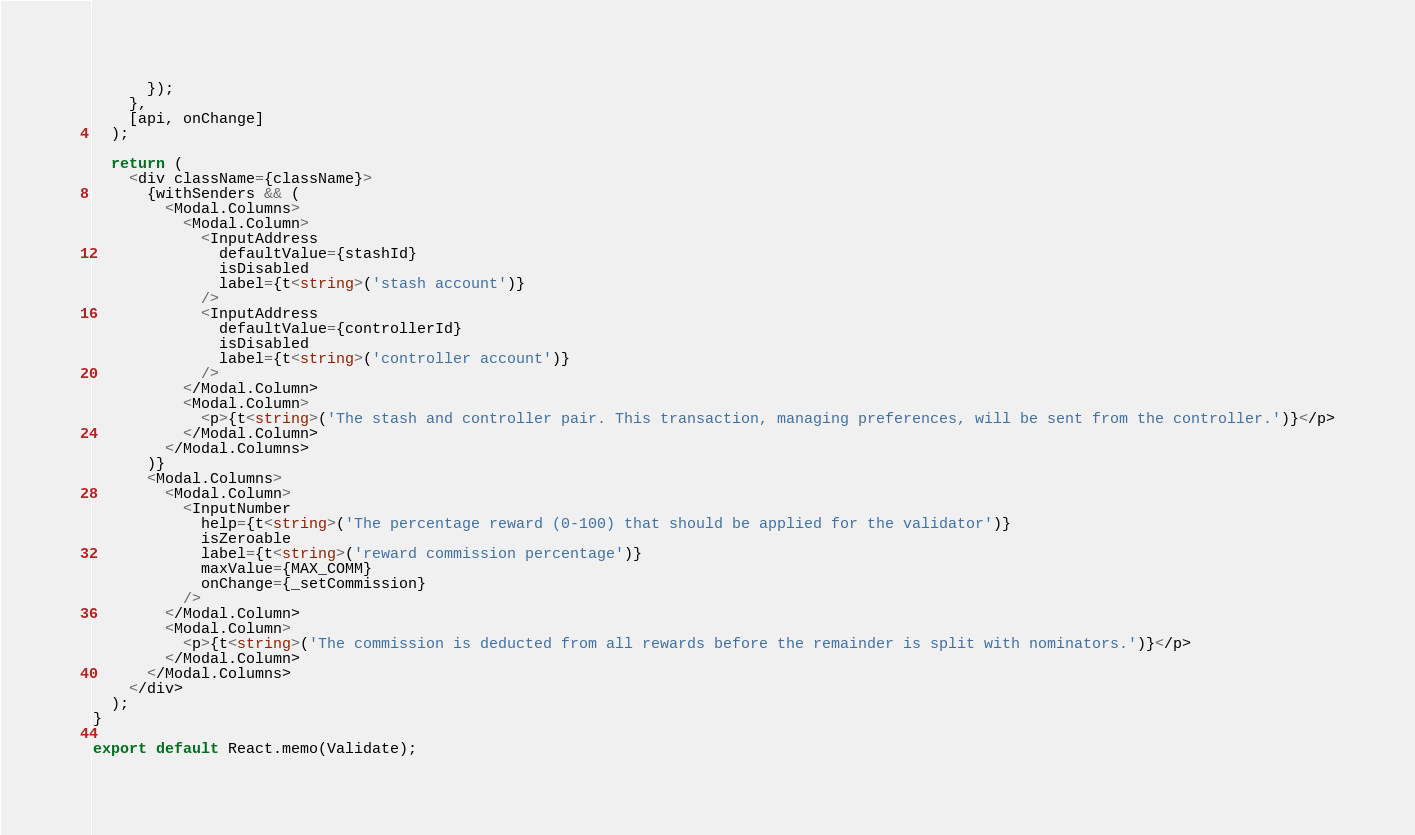Convert code to text. <code><loc_0><loc_0><loc_500><loc_500><_TypeScript_>      });
    },
    [api, onChange]
  );

  return (
    <div className={className}>
      {withSenders && (
        <Modal.Columns>
          <Modal.Column>
            <InputAddress
              defaultValue={stashId}
              isDisabled
              label={t<string>('stash account')}
            />
            <InputAddress
              defaultValue={controllerId}
              isDisabled
              label={t<string>('controller account')}
            />
          </Modal.Column>
          <Modal.Column>
            <p>{t<string>('The stash and controller pair. This transaction, managing preferences, will be sent from the controller.')}</p>
          </Modal.Column>
        </Modal.Columns>
      )}
      <Modal.Columns>
        <Modal.Column>
          <InputNumber
            help={t<string>('The percentage reward (0-100) that should be applied for the validator')}
            isZeroable
            label={t<string>('reward commission percentage')}
            maxValue={MAX_COMM}
            onChange={_setCommission}
          />
        </Modal.Column>
        <Modal.Column>
          <p>{t<string>('The commission is deducted from all rewards before the remainder is split with nominators.')}</p>
        </Modal.Column>
      </Modal.Columns>
    </div>
  );
}

export default React.memo(Validate);
</code> 